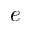<formula> <loc_0><loc_0><loc_500><loc_500>e</formula> 